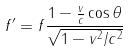<formula> <loc_0><loc_0><loc_500><loc_500>f ^ { \prime } = f \frac { 1 - \frac { v } { c } \cos \theta } { \sqrt { 1 - v ^ { 2 } / c ^ { 2 } } }</formula> 